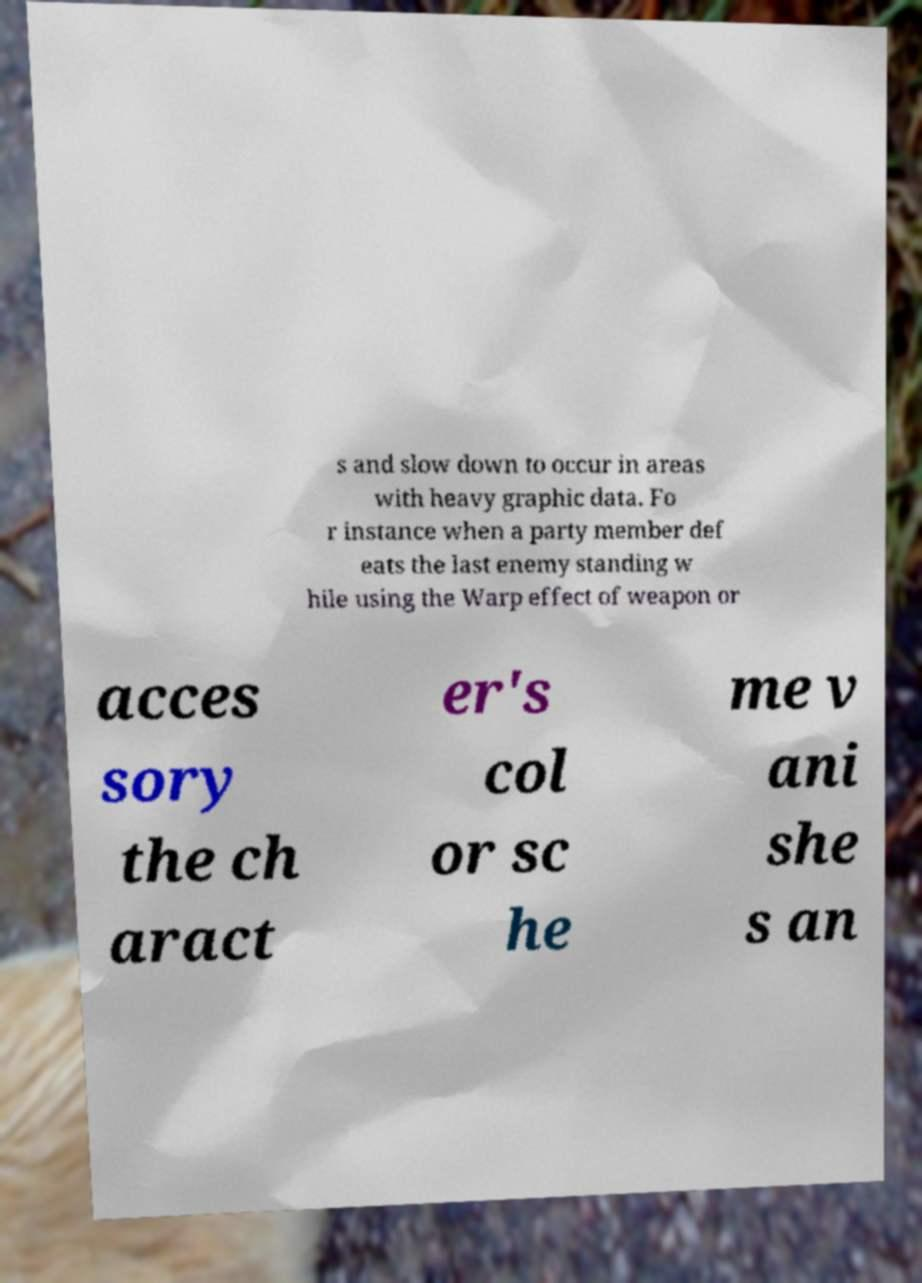For documentation purposes, I need the text within this image transcribed. Could you provide that? s and slow down to occur in areas with heavy graphic data. Fo r instance when a party member def eats the last enemy standing w hile using the Warp effect of weapon or acces sory the ch aract er's col or sc he me v ani she s an 